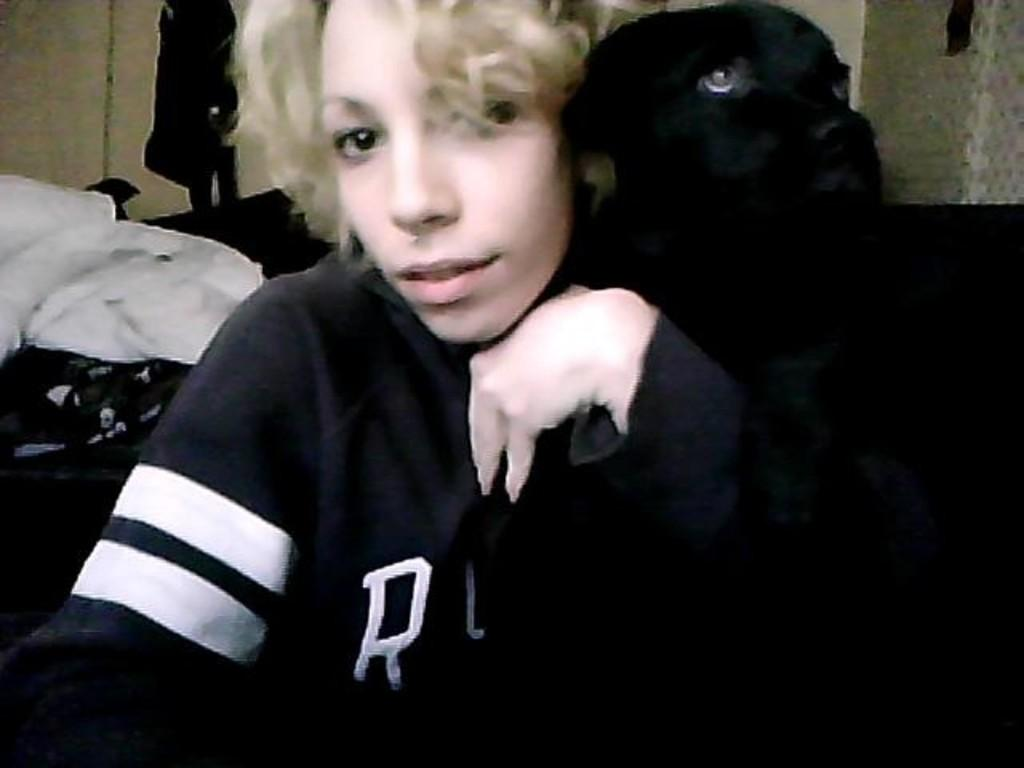Who or what is present in the image? There is a person in the image. What is the person wearing? The person is wearing a black hoodie. Are there any animals in the image? Yes, there is a dog in the image. What type of prose can be seen on the scarecrow in the image? There is no scarecrow present in the image, and therefore no prose can be seen on it. 